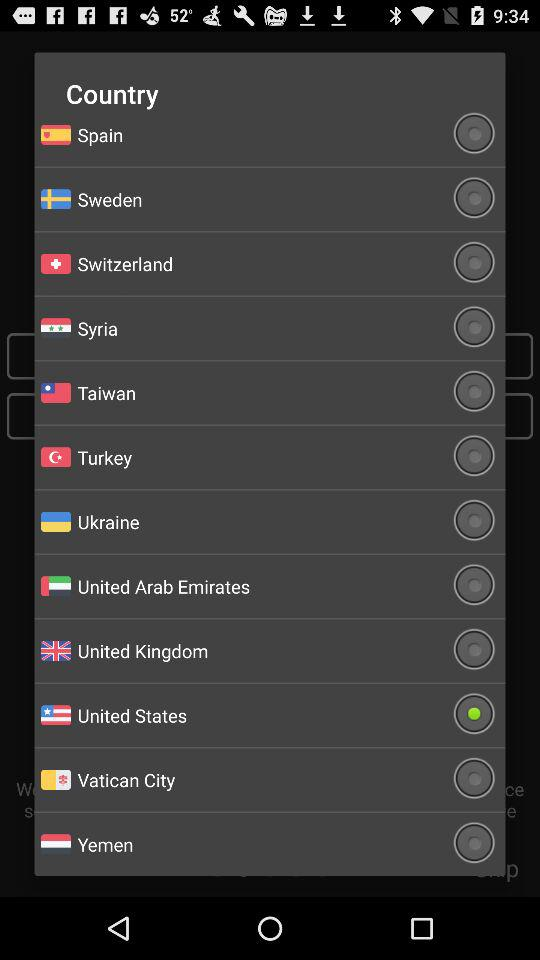Is Spain selected or not? It is not selected. 